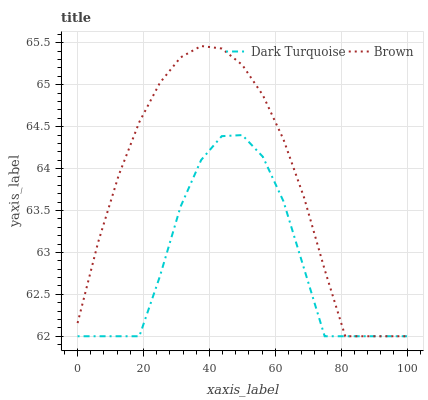Does Dark Turquoise have the minimum area under the curve?
Answer yes or no. Yes. Does Brown have the maximum area under the curve?
Answer yes or no. Yes. Does Brown have the minimum area under the curve?
Answer yes or no. No. Is Brown the smoothest?
Answer yes or no. Yes. Is Dark Turquoise the roughest?
Answer yes or no. Yes. Is Brown the roughest?
Answer yes or no. No. Does Dark Turquoise have the lowest value?
Answer yes or no. Yes. Does Brown have the highest value?
Answer yes or no. Yes. Does Dark Turquoise intersect Brown?
Answer yes or no. Yes. Is Dark Turquoise less than Brown?
Answer yes or no. No. Is Dark Turquoise greater than Brown?
Answer yes or no. No. 